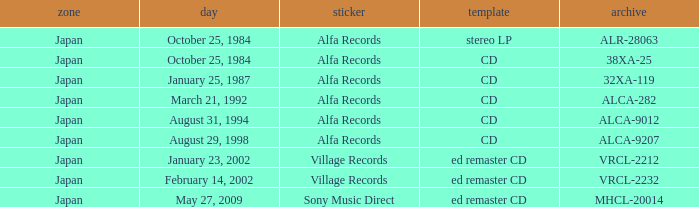What is the region of the release of a CD with catalog 32xa-119? Japan. 